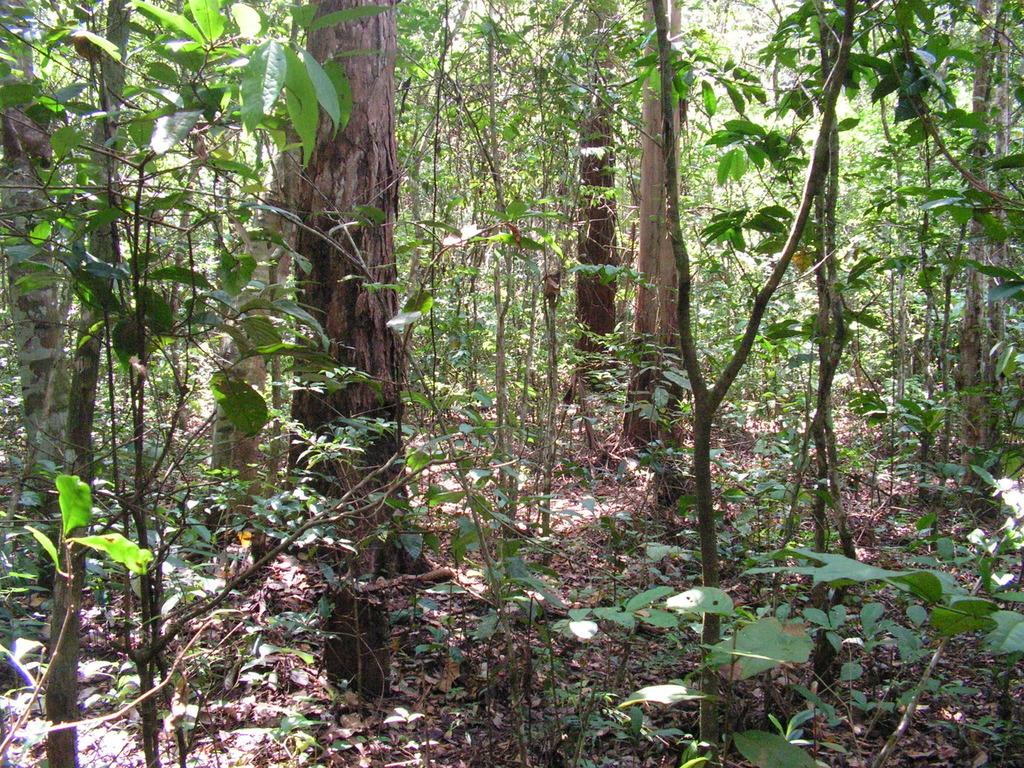What type of vegetation can be seen in the image? There are plants and trees in the image. Can you describe the plants and trees in the image? The image shows plants and trees, but it does not provide specific details about their types or characteristics. What is the tax rate for the pencil in the image? There is no pencil present in the image, and therefore no tax rate can be determined. 